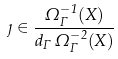Convert formula to latex. <formula><loc_0><loc_0><loc_500><loc_500>\eta \in \frac { \Omega ^ { - 1 } _ { \Gamma } ( X ) } { d _ { \Gamma } \, \Omega ^ { - 2 } _ { \Gamma } ( X ) }</formula> 